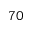Convert formula to latex. <formula><loc_0><loc_0><loc_500><loc_500>^ { 7 } 0</formula> 